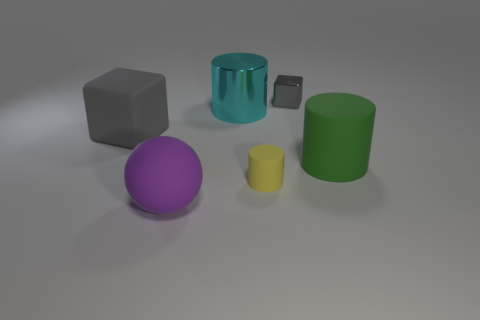What number of big objects are either rubber objects or balls?
Give a very brief answer. 3. There is a big thing that is both on the right side of the large sphere and behind the big green thing; what is its shape?
Ensure brevity in your answer.  Cylinder. Does the yellow cylinder have the same material as the big purple object?
Give a very brief answer. Yes. The cylinder that is the same size as the gray shiny cube is what color?
Ensure brevity in your answer.  Yellow. The object that is in front of the cyan cylinder and right of the yellow rubber cylinder is what color?
Give a very brief answer. Green. What size is the other cube that is the same color as the metal block?
Offer a very short reply. Large. What shape is the tiny object that is the same color as the big block?
Provide a short and direct response. Cube. There is a metal object that is right of the metallic cylinder in front of the cube on the right side of the small yellow rubber thing; what size is it?
Your answer should be very brief. Small. What is the material of the yellow thing?
Your answer should be compact. Rubber. Does the large purple thing have the same material as the small object that is in front of the gray metallic block?
Offer a terse response. Yes. 